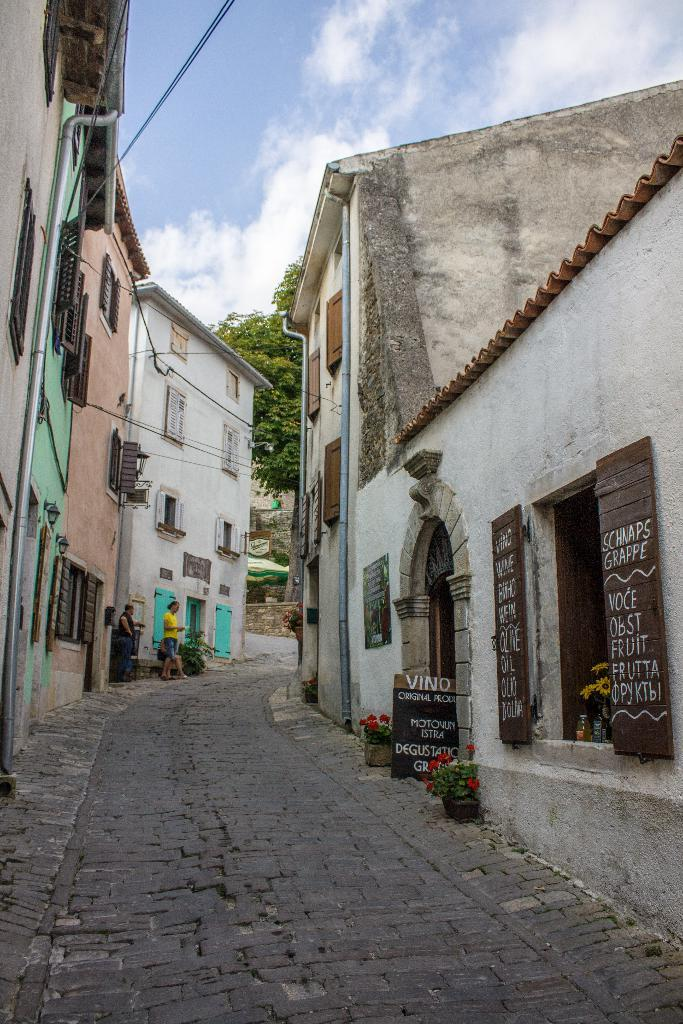What is the main feature of the image? There is a road in the image. What type of structures can be seen along the road? There are buildings with windows in the image. What other objects can be seen in the image? Pipes, boards, house plants, and a tree are present in the image. What is happening in the image? Two persons are walking in the image. What can be seen in the background of the image? The sky with clouds is visible in the background of the image. What idea does the boy have while walking in the image? There is no boy present in the image; it features two persons walking. 